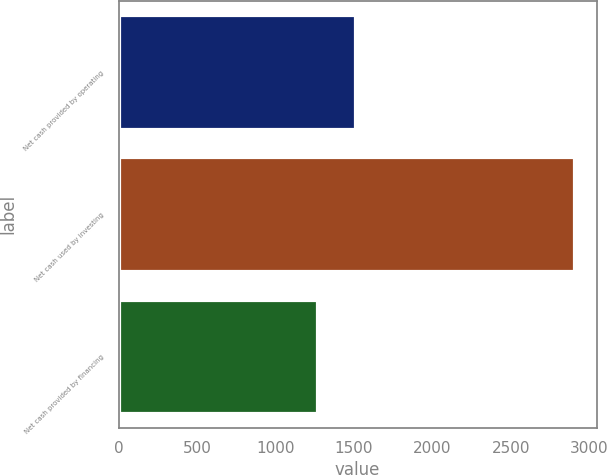<chart> <loc_0><loc_0><loc_500><loc_500><bar_chart><fcel>Net cash provided by operating<fcel>Net cash used by investing<fcel>Net cash provided by financing<nl><fcel>1510<fcel>2903<fcel>1265<nl></chart> 